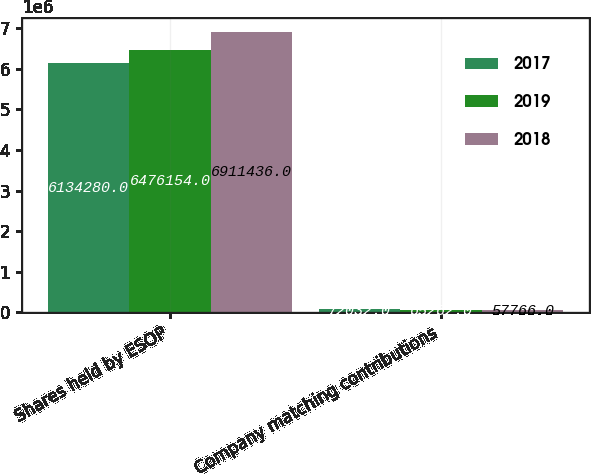<chart> <loc_0><loc_0><loc_500><loc_500><stacked_bar_chart><ecel><fcel>Shares held by ESOP<fcel>Company matching contributions<nl><fcel>2017<fcel>6.13428e+06<fcel>72032<nl><fcel>2019<fcel>6.47615e+06<fcel>65262<nl><fcel>2018<fcel>6.91144e+06<fcel>57766<nl></chart> 